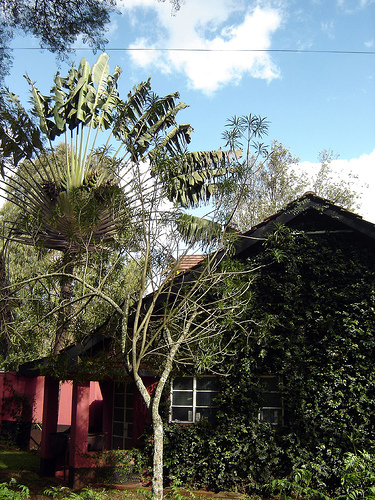<image>
Can you confirm if the sky is behind the building? Yes. From this viewpoint, the sky is positioned behind the building, with the building partially or fully occluding the sky. 